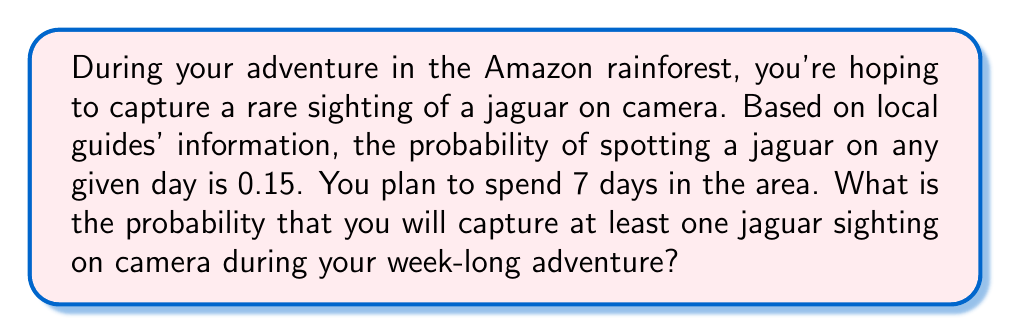What is the answer to this math problem? Let's approach this step-by-step:

1) First, we need to recognize that this is a binomial probability problem. We're looking for the probability of at least one success (jaguar sighting) in 7 trials (days).

2) It's often easier to calculate the probability of at least one success by subtracting the probability of no success from 1.

3) Let $p$ be the probability of success on a single day, and $q$ be the probability of failure:
   $p = 0.15$
   $q = 1 - p = 0.85$

4) The probability of no jaguar sightings in 7 days is:
   $P(\text{no sightings}) = q^7 = 0.85^7$

5) Calculate this:
   $0.85^7 \approx 0.3164$

6) Therefore, the probability of at least one sighting is:
   $P(\text{at least one sighting}) = 1 - P(\text{no sightings})$
   $= 1 - 0.3164 = 0.6836$

7) Convert to a percentage:
   $0.6836 \times 100\% = 68.36\%$
Answer: $68.36\%$ 